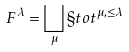Convert formula to latex. <formula><loc_0><loc_0><loc_500><loc_500>\ F ^ { \lambda } = \bigsqcup _ { \mu } \S t o t ^ { \mu , \leq \lambda }</formula> 